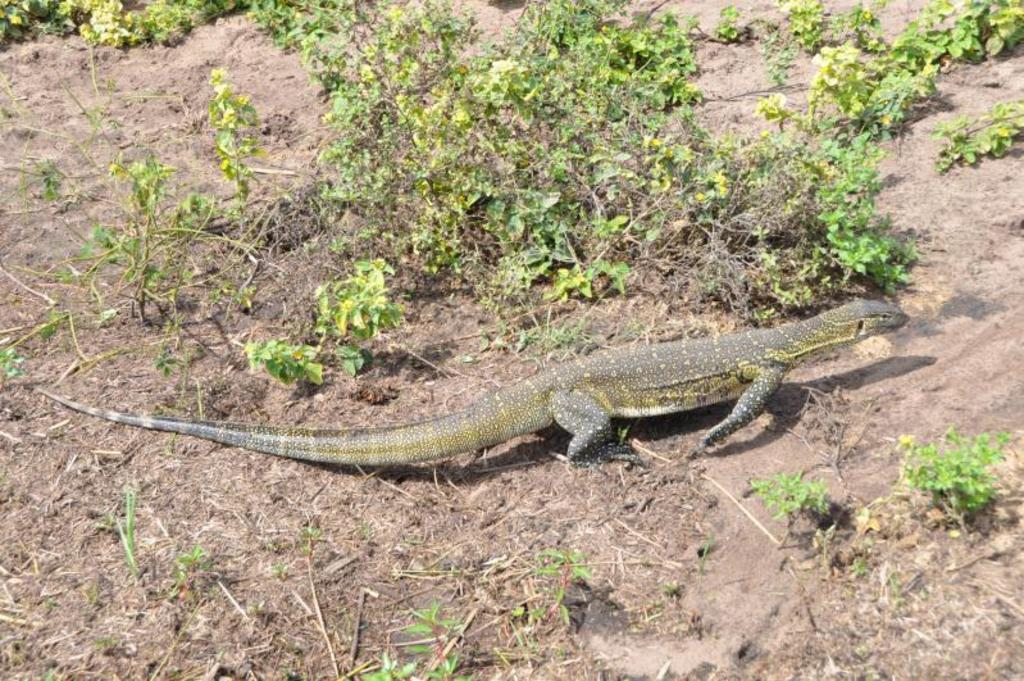What type of animal is on the ground in the image? There is a reptile on the ground in the image. What can be seen in the background of the image? There are plants in the background of the image. How many minutes does the reptile take to unscrew the screw in the image? There is no screw present in the image, and therefore no such activity can be observed. 